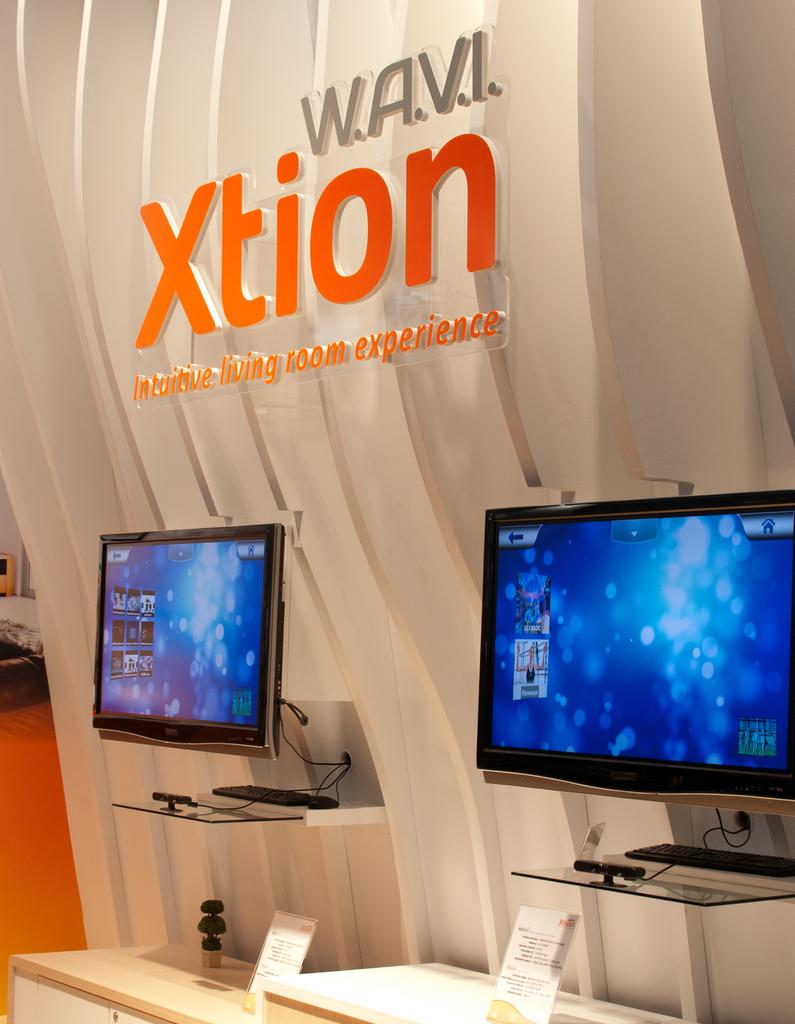What is the brand on the wall?
Offer a very short reply. Xtion. 